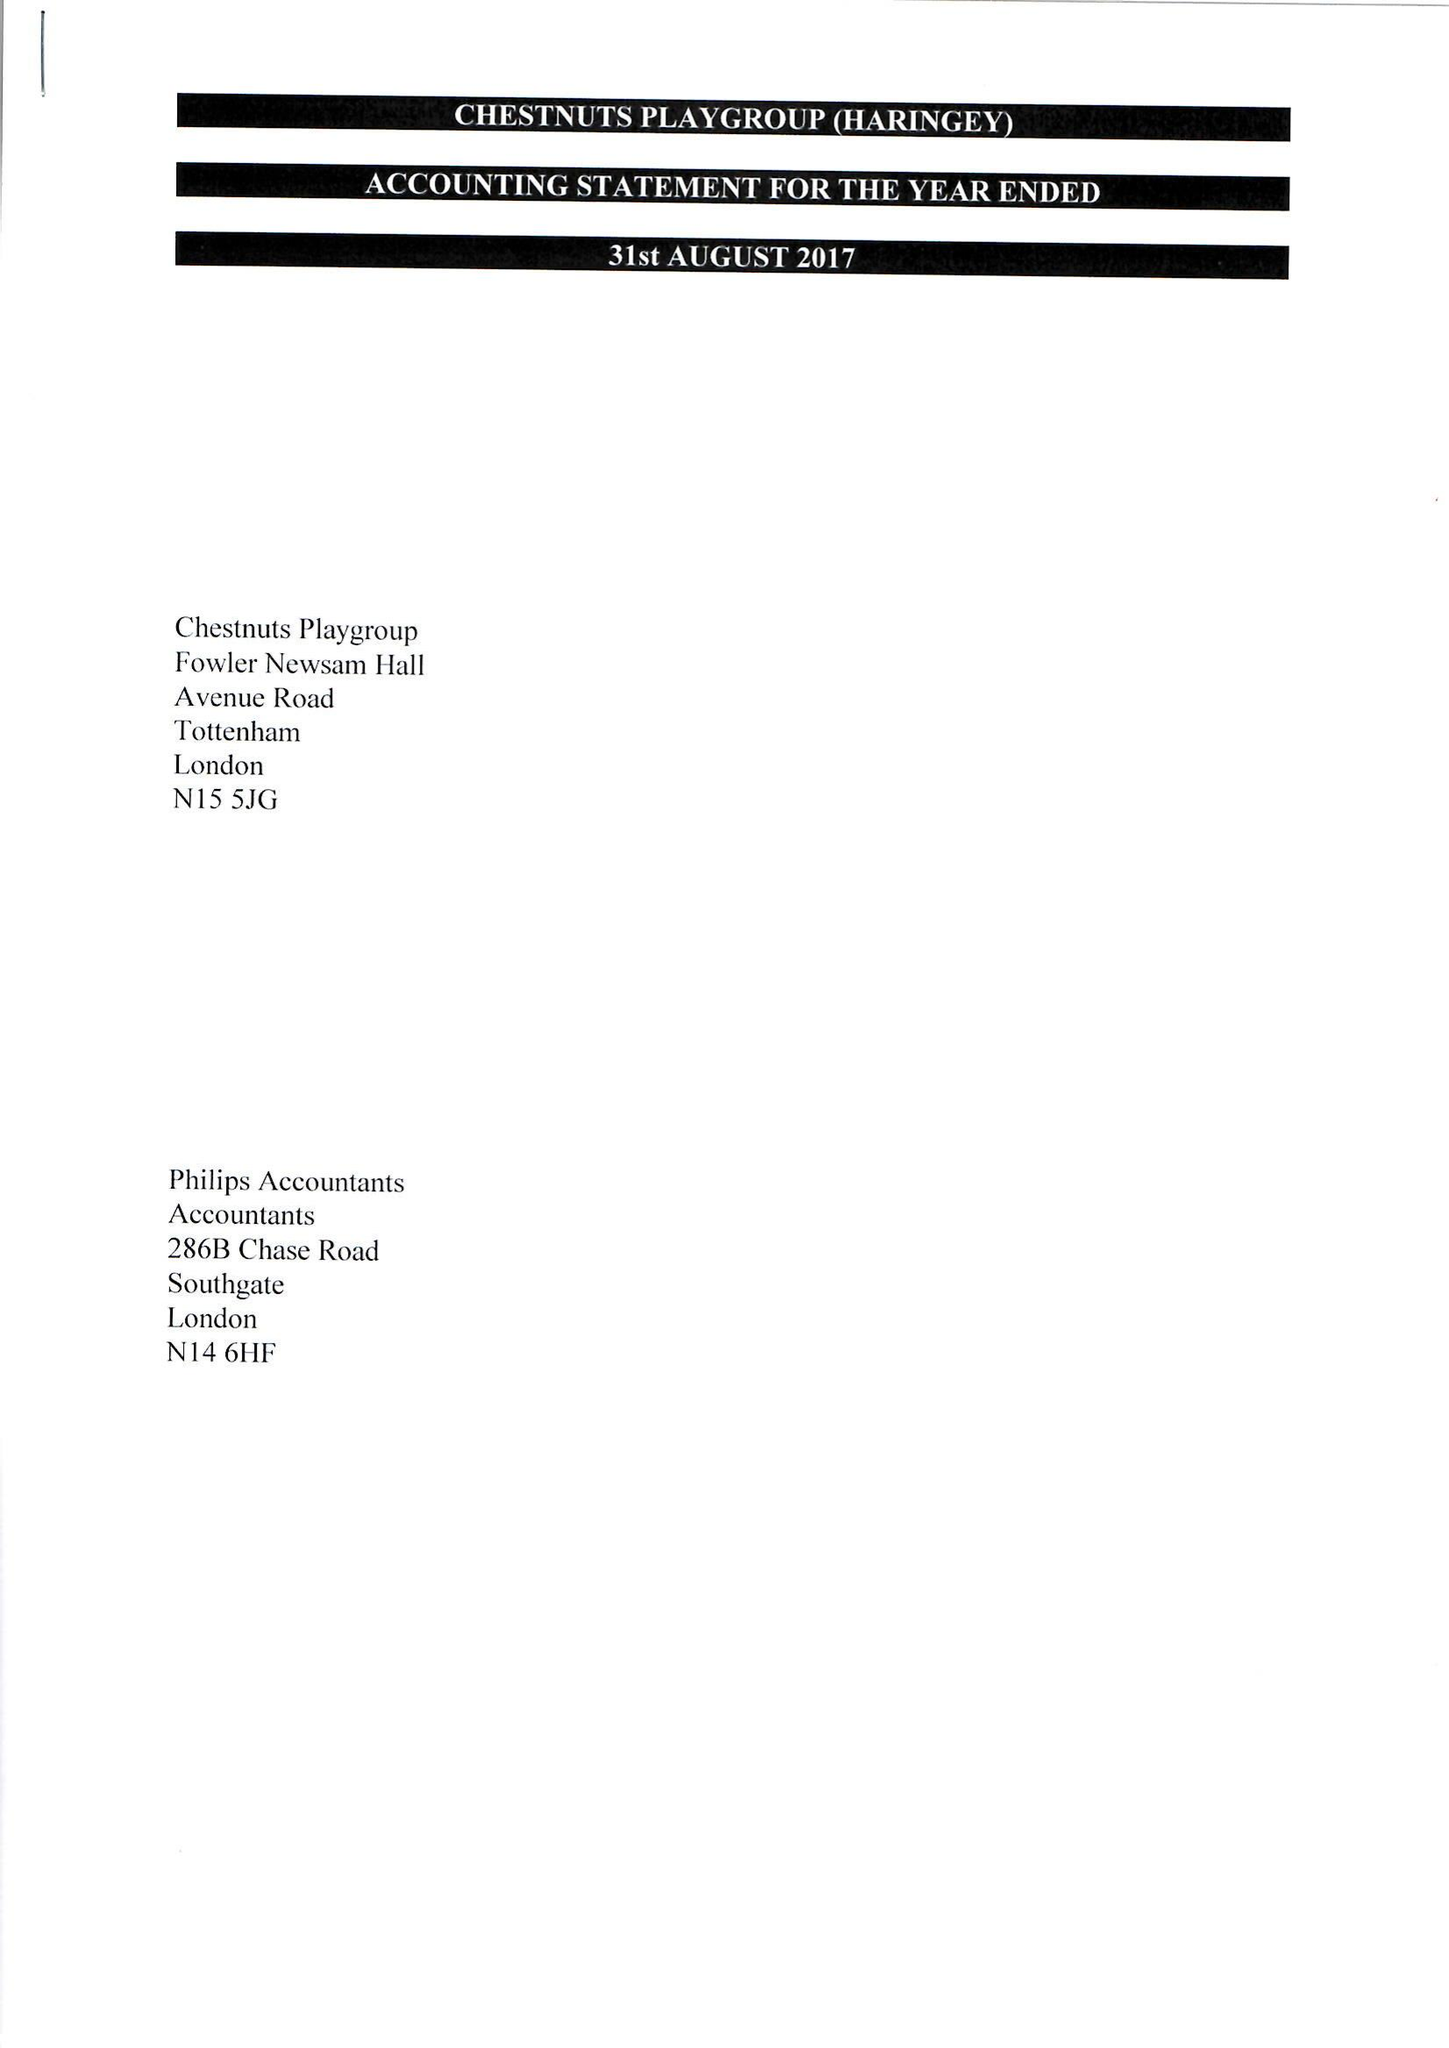What is the value for the charity_name?
Answer the question using a single word or phrase. Chestnuts Playgroup (Haringey) 